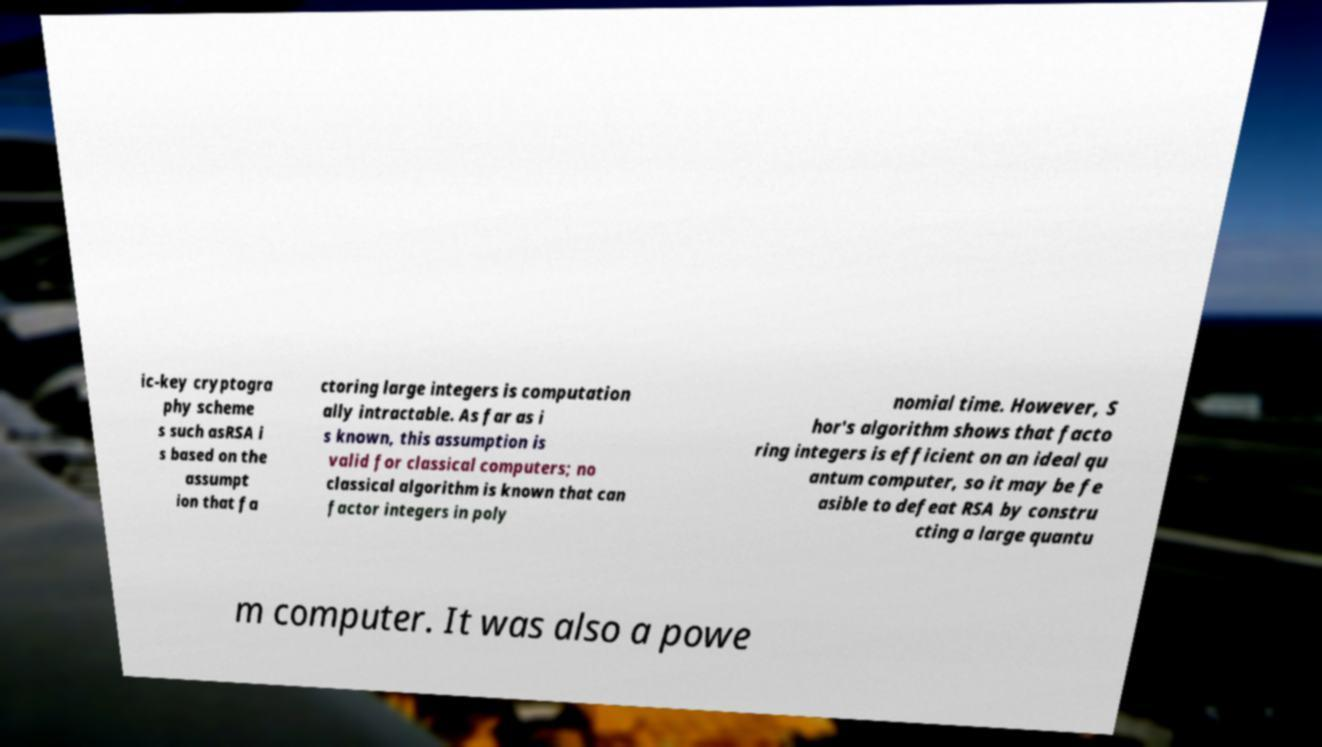I need the written content from this picture converted into text. Can you do that? ic-key cryptogra phy scheme s such asRSA i s based on the assumpt ion that fa ctoring large integers is computation ally intractable. As far as i s known, this assumption is valid for classical computers; no classical algorithm is known that can factor integers in poly nomial time. However, S hor's algorithm shows that facto ring integers is efficient on an ideal qu antum computer, so it may be fe asible to defeat RSA by constru cting a large quantu m computer. It was also a powe 